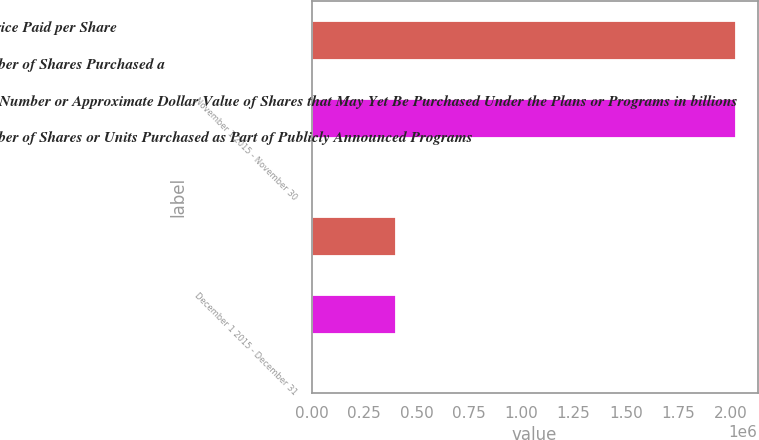Convert chart to OTSL. <chart><loc_0><loc_0><loc_500><loc_500><stacked_bar_chart><ecel><fcel>November 1 2015 - November 30<fcel>December 1 2015 - December 31<nl><fcel>Average Price Paid per Share<fcel>2.028e+06<fcel>404562<nl><fcel>Total Number of Shares Purchased a<fcel>41.05<fcel>41.8<nl><fcel>Maximum Number or Approximate Dollar Value of Shares that May Yet Be Purchased Under the Plans or Programs in billions<fcel>2.02764e+06<fcel>402163<nl><fcel>Total Number of Shares or Units Purchased as Part of Publicly Announced Programs<fcel>1.05<fcel>1.03<nl></chart> 